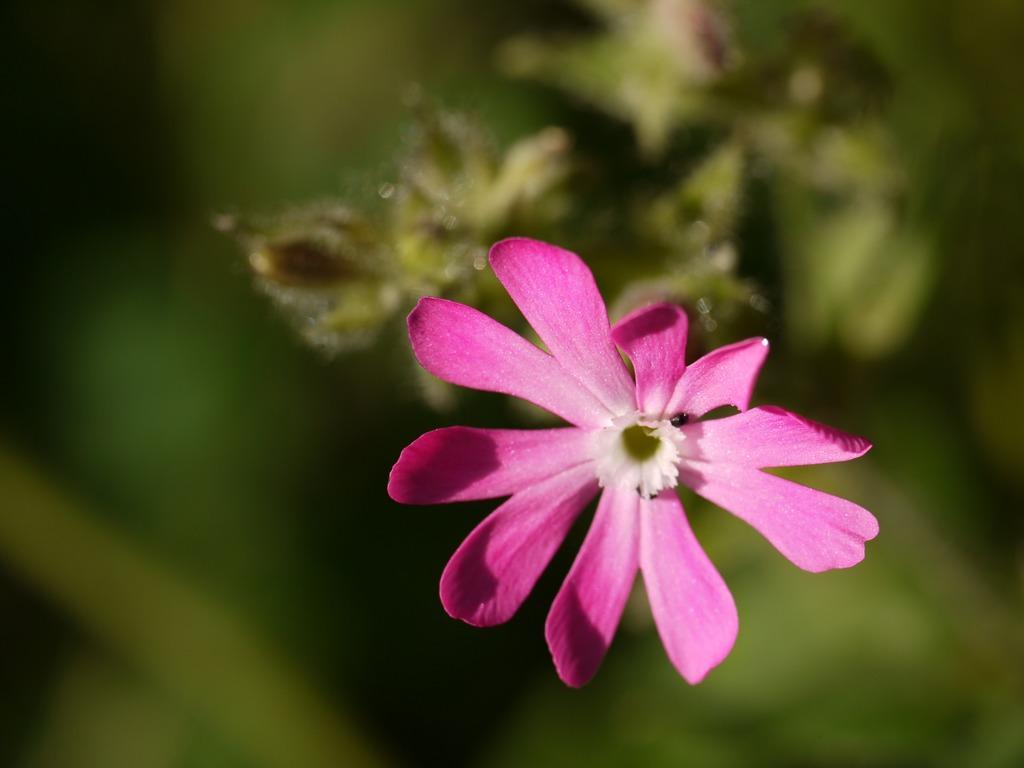In one or two sentences, can you explain what this image depicts? This image consists of a flower in pink color along with a plant. And the background is blurred. 